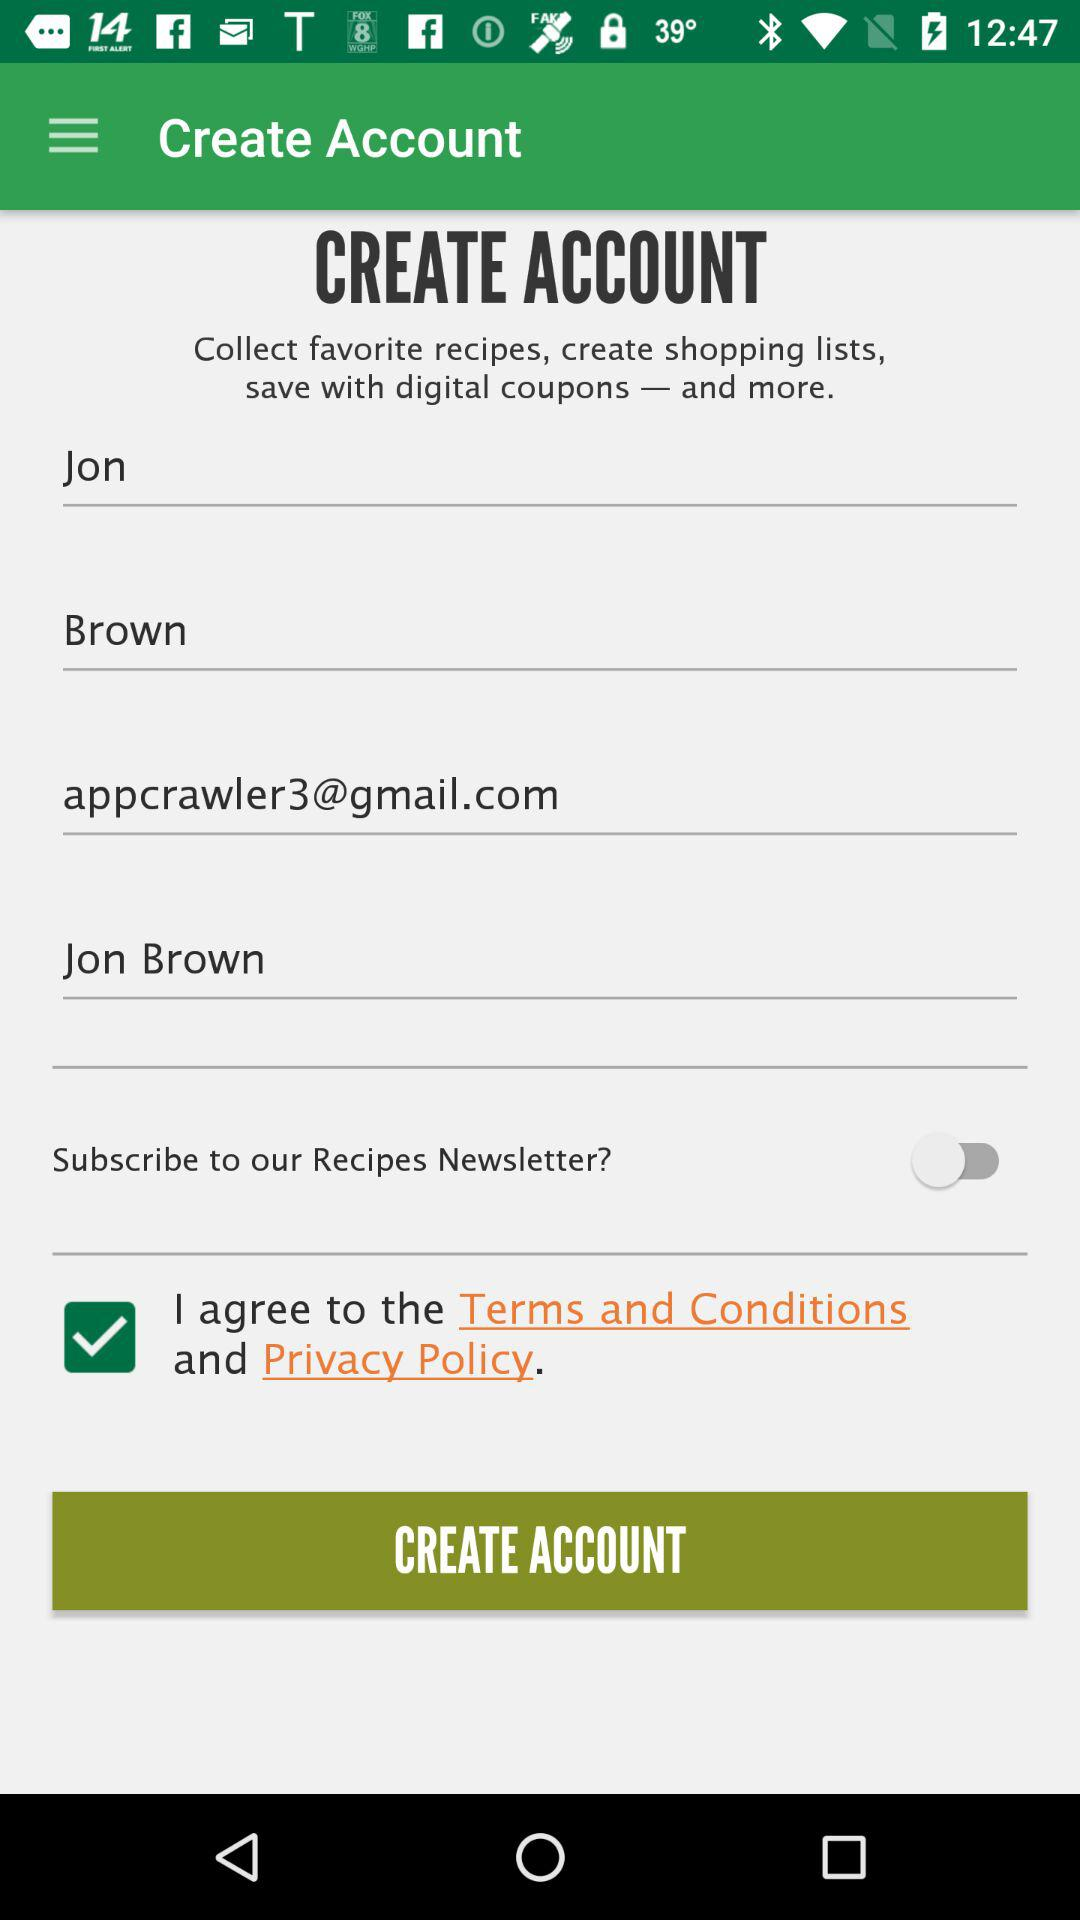What option is checked? The checked option is "I agree to the Terms and Conditions and Privacy Policy". 